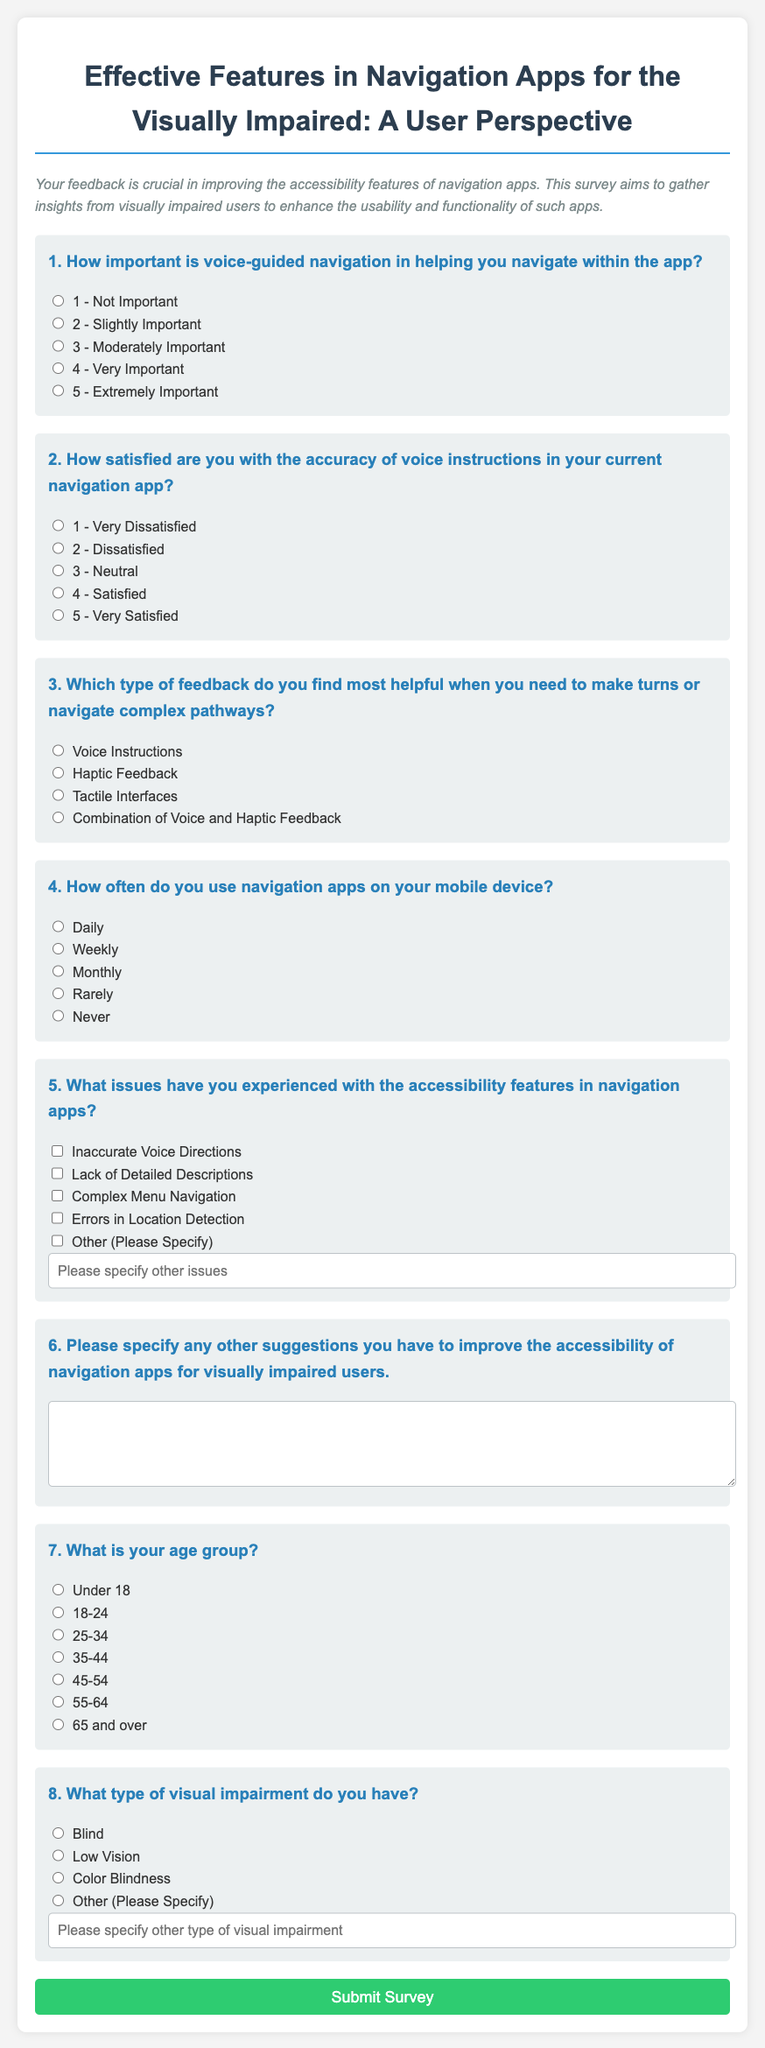What is the title of the survey? The title is the main heading of the document that identifies the purpose of the survey for visually impaired users.
Answer: Effective Features in Navigation Apps for the Visually Impaired: A User Perspective What is the main purpose of the survey? The main purpose is stated in the description section that explains the feedback being gathered from visually impaired users.
Answer: To gather insights to enhance the usability and functionality of navigation apps How many questions are in the survey? The survey consists of the total number of questions listed in the form, which is indicated in the structure of the document.
Answer: 8 What type of feedback is considered most helpful for navigation? This refers to the specific question regarding helpful feedback when making turns or navigating pathways within the survey.
Answer: Combination of Voice and Haptic Feedback What options are provided for the user's age group? This query seeks information about the available age group options presented in the survey response section.
Answer: Under 18, 18-24, 25-34, 35-44, 45-54, 55-64, 65 and over How is the survey submitted? The submission process is indicated by the format of the button included at the end of the survey form.
Answer: By clicking the "Submit Survey" button 